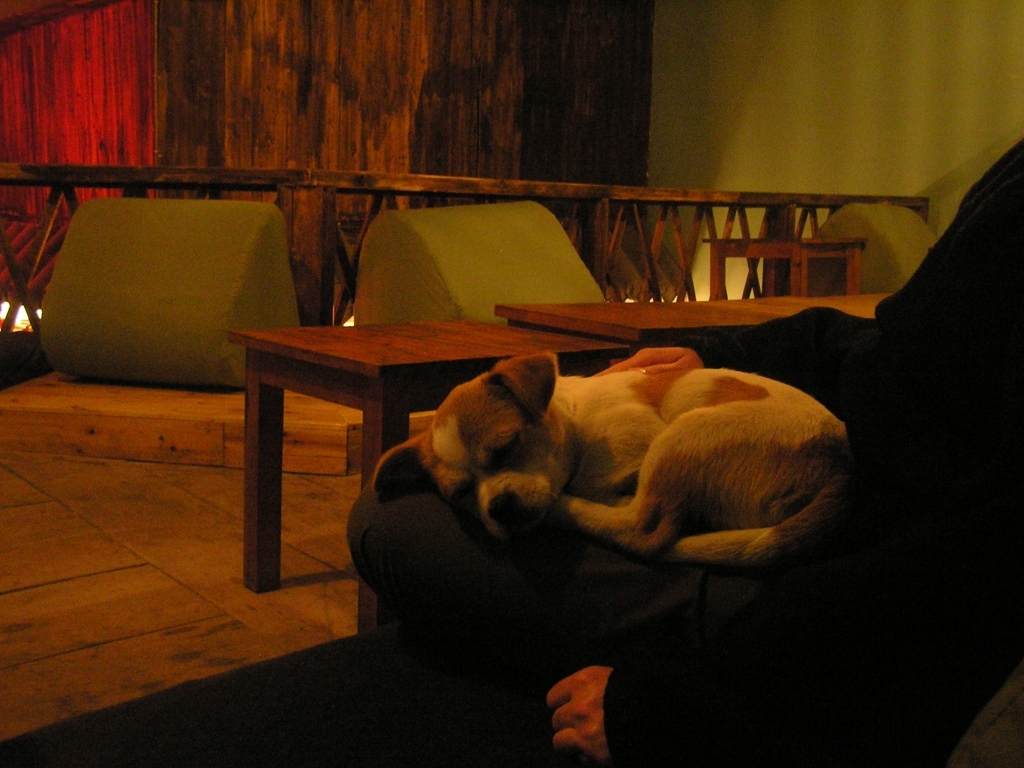What breed might the dog be? It's a bit challenging to determine the exact breed from this angle, but the dog appears to be a small to medium-sized breed, perhaps with some characteristics of a terrier or a hound based on its coat pattern and ear shape. Does the setting look like a public space or a private home? The setting appears to be a cozy, casual public space, possibly a cafe or a lounge area, given the multiple seating arrangements and tables in the background. 